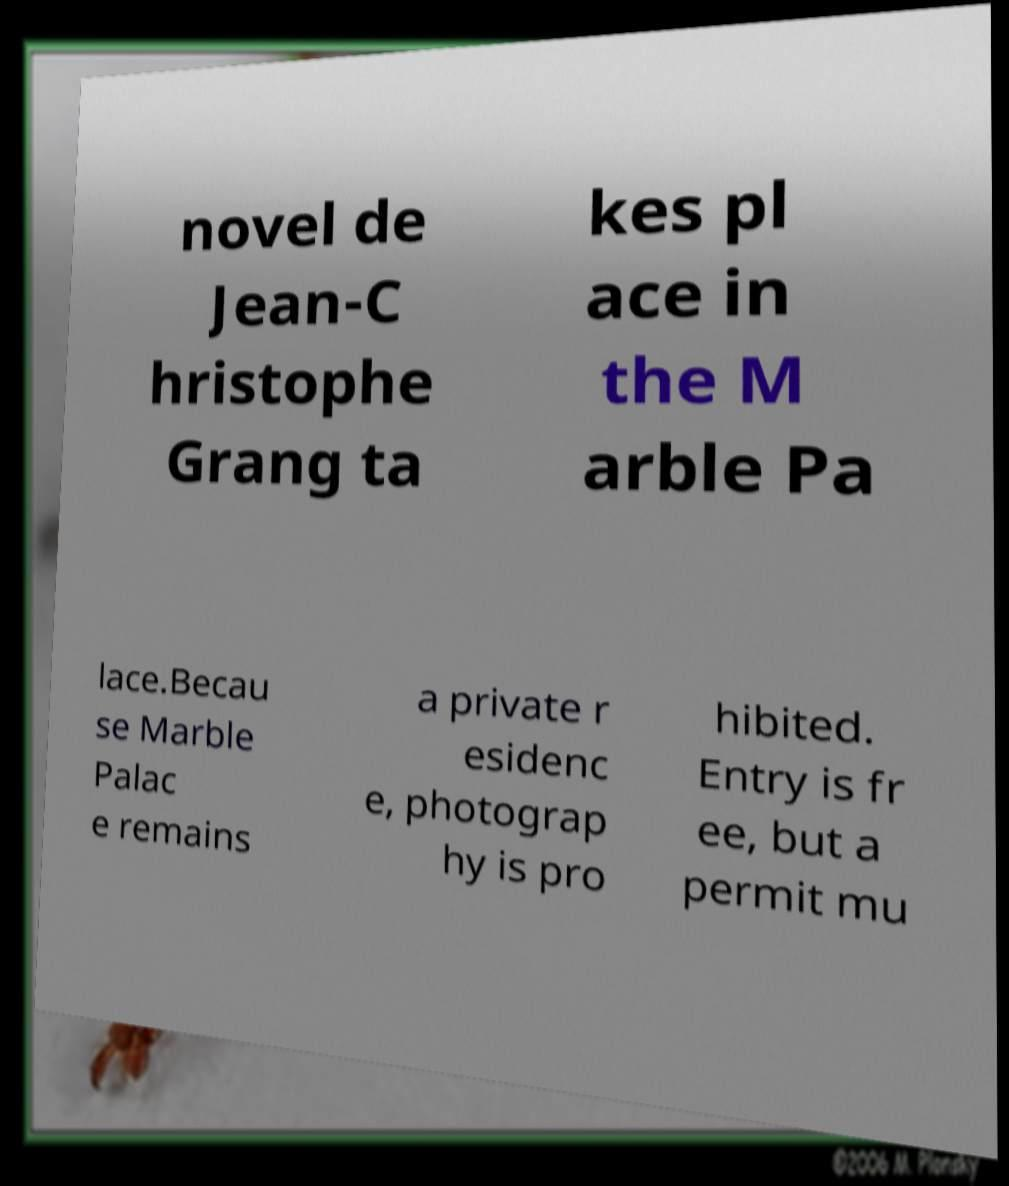I need the written content from this picture converted into text. Can you do that? novel de Jean-C hristophe Grang ta kes pl ace in the M arble Pa lace.Becau se Marble Palac e remains a private r esidenc e, photograp hy is pro hibited. Entry is fr ee, but a permit mu 